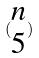<formula> <loc_0><loc_0><loc_500><loc_500>( \begin{matrix} n \\ 5 \end{matrix} )</formula> 